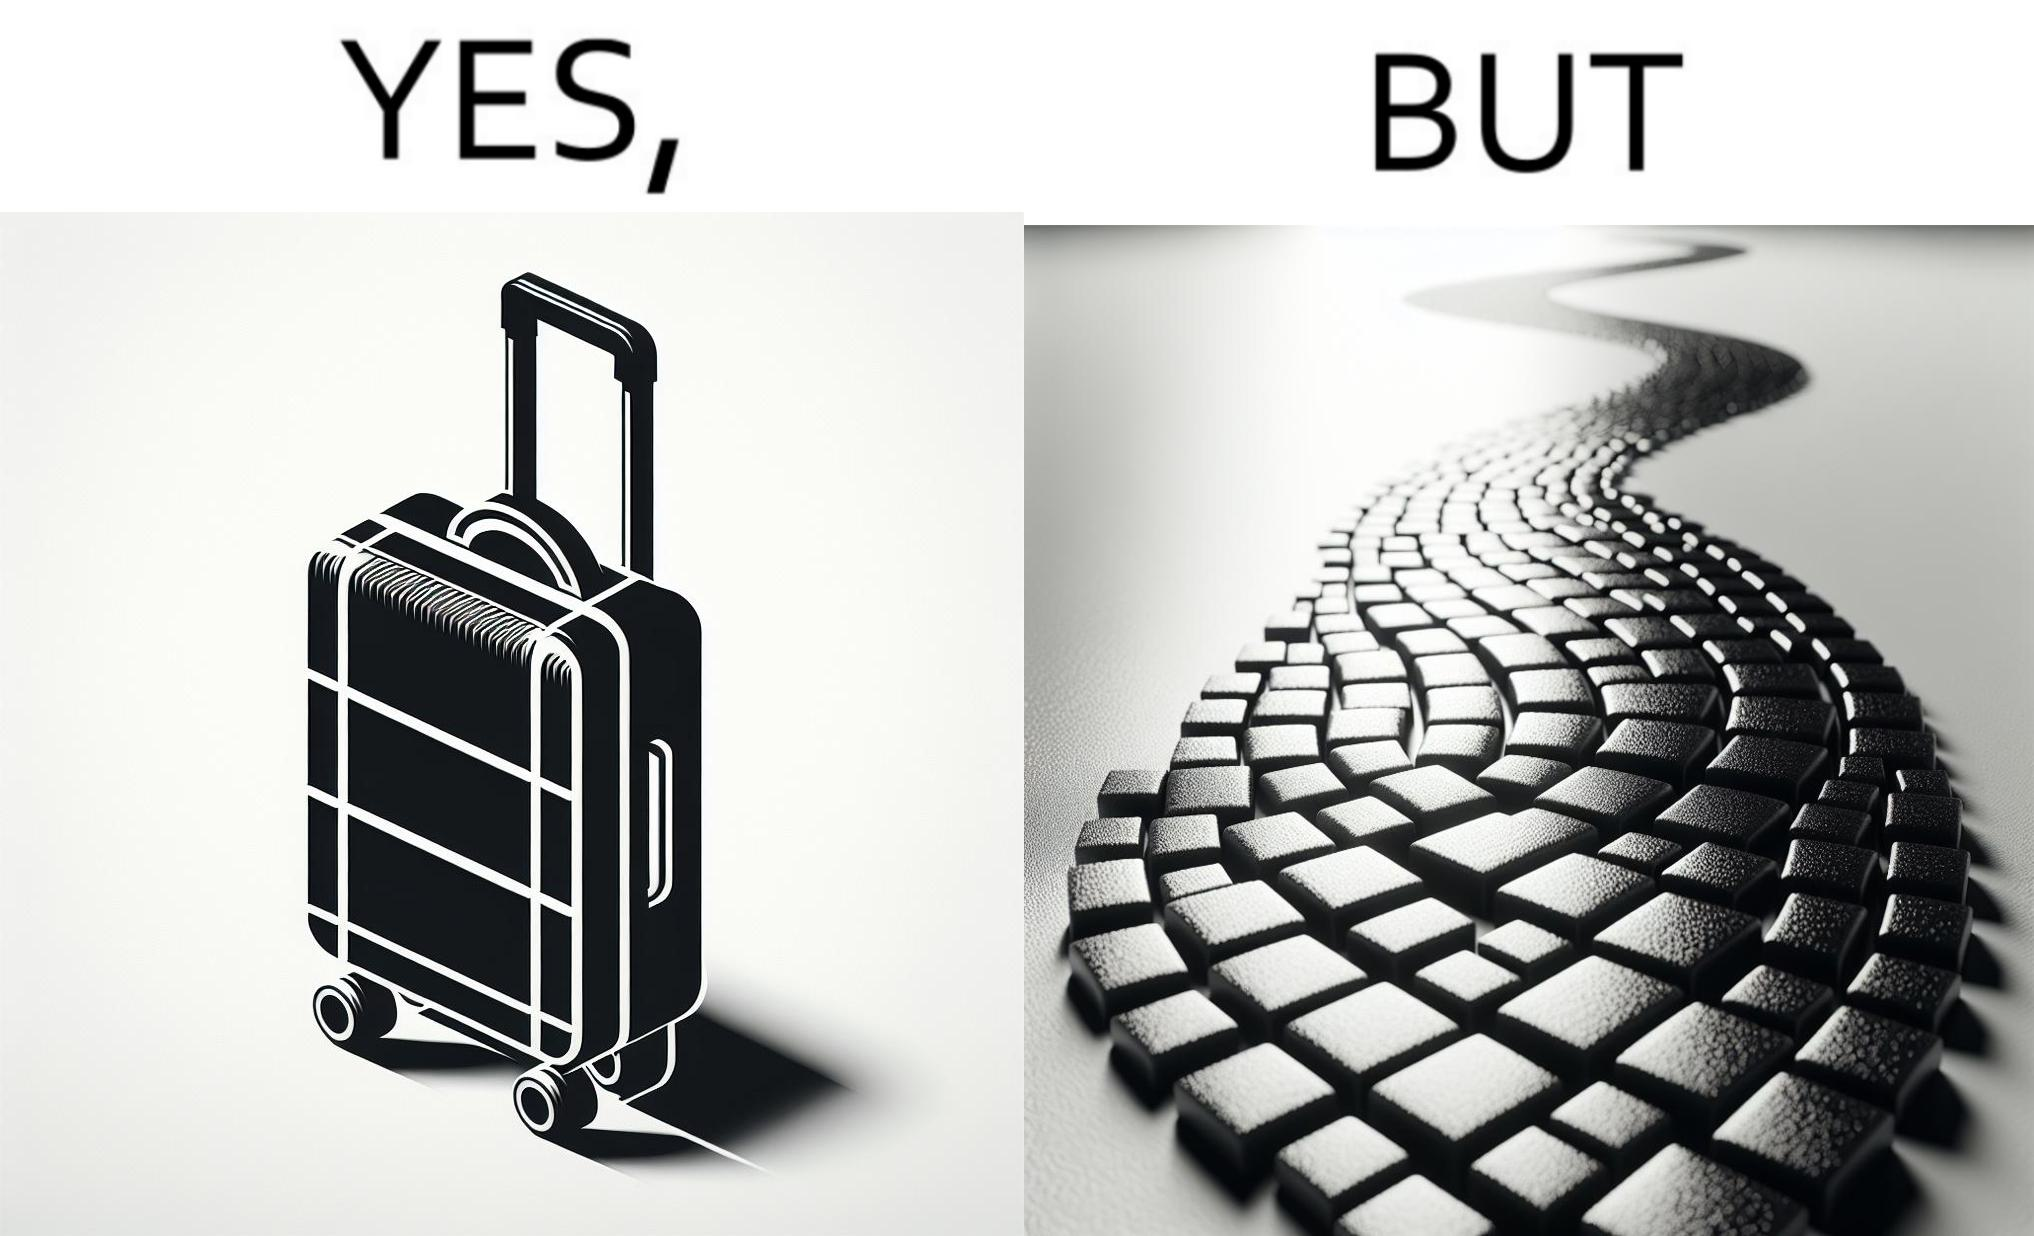Why is this image considered satirical? The image is funny because even though the trolley bag is made to make carrying luggage easy, as soon as it encounters a rough surface like cobblestone road, it makes carrying luggage more difficult. 